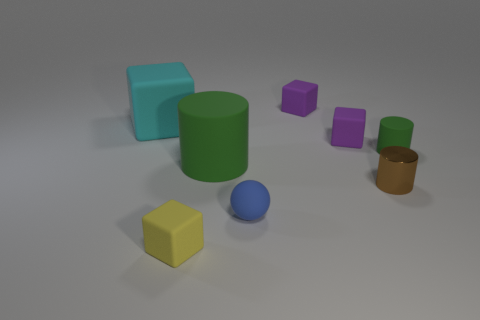Is there anything else that is made of the same material as the brown cylinder?
Your response must be concise. No. What size is the thing that is the same color as the large cylinder?
Make the answer very short. Small. There is a cylinder that is on the right side of the small brown object; is it the same color as the big matte cylinder?
Your response must be concise. Yes. What number of other tiny matte objects are the same shape as the small brown object?
Your answer should be very brief. 1. What material is the purple thing that is behind the big cyan matte block that is left of the blue matte ball made of?
Your answer should be compact. Rubber. There is a large object that is the same color as the tiny matte cylinder; what shape is it?
Make the answer very short. Cylinder. Are there any large cyan blocks that have the same material as the tiny sphere?
Keep it short and to the point. Yes. What is the shape of the large green thing?
Your response must be concise. Cylinder. What number of small brown rubber spheres are there?
Offer a very short reply. 0. What color is the small block in front of the tiny purple object that is in front of the cyan matte object?
Make the answer very short. Yellow. 